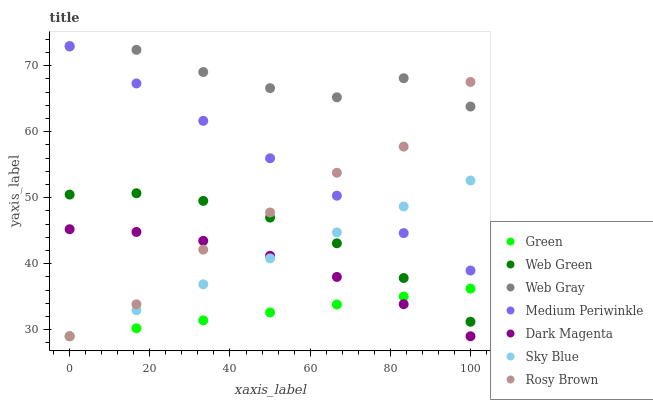Does Green have the minimum area under the curve?
Answer yes or no. Yes. Does Web Gray have the maximum area under the curve?
Answer yes or no. Yes. Does Dark Magenta have the minimum area under the curve?
Answer yes or no. No. Does Dark Magenta have the maximum area under the curve?
Answer yes or no. No. Is Sky Blue the smoothest?
Answer yes or no. Yes. Is Web Gray the roughest?
Answer yes or no. Yes. Is Dark Magenta the smoothest?
Answer yes or no. No. Is Dark Magenta the roughest?
Answer yes or no. No. Does Dark Magenta have the lowest value?
Answer yes or no. Yes. Does Medium Periwinkle have the lowest value?
Answer yes or no. No. Does Medium Periwinkle have the highest value?
Answer yes or no. Yes. Does Dark Magenta have the highest value?
Answer yes or no. No. Is Green less than Medium Periwinkle?
Answer yes or no. Yes. Is Medium Periwinkle greater than Dark Magenta?
Answer yes or no. Yes. Does Rosy Brown intersect Dark Magenta?
Answer yes or no. Yes. Is Rosy Brown less than Dark Magenta?
Answer yes or no. No. Is Rosy Brown greater than Dark Magenta?
Answer yes or no. No. Does Green intersect Medium Periwinkle?
Answer yes or no. No. 